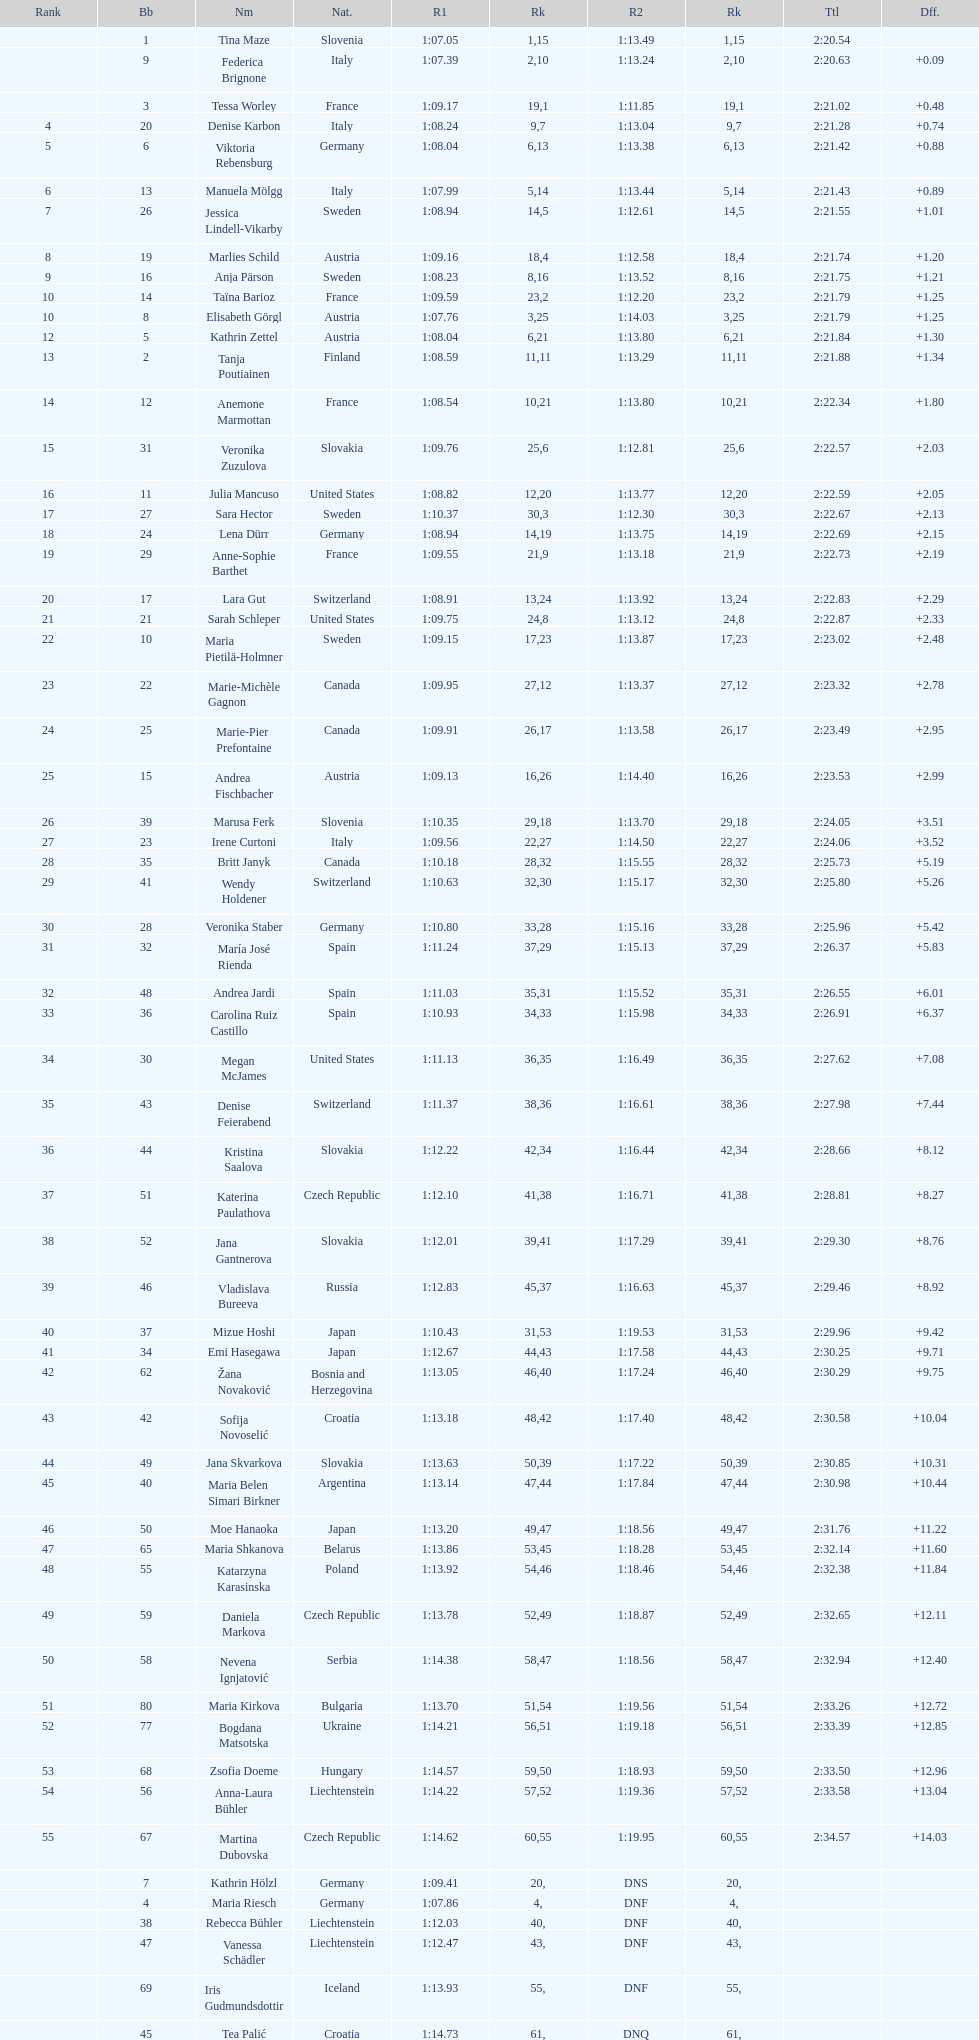How many total names are there? 116. 